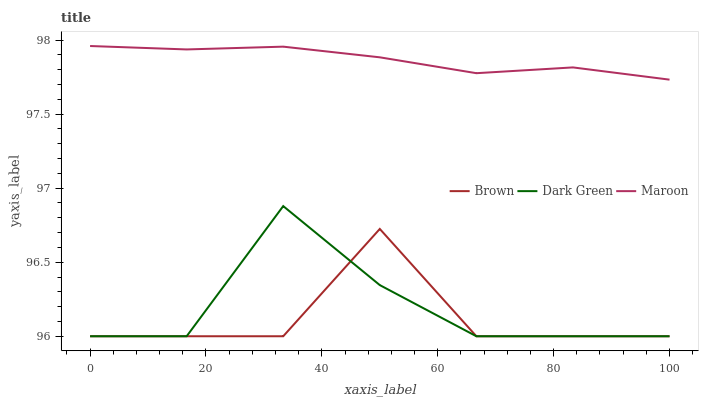Does Brown have the minimum area under the curve?
Answer yes or no. Yes. Does Maroon have the maximum area under the curve?
Answer yes or no. Yes. Does Dark Green have the minimum area under the curve?
Answer yes or no. No. Does Dark Green have the maximum area under the curve?
Answer yes or no. No. Is Maroon the smoothest?
Answer yes or no. Yes. Is Brown the roughest?
Answer yes or no. Yes. Is Dark Green the smoothest?
Answer yes or no. No. Is Dark Green the roughest?
Answer yes or no. No. Does Brown have the lowest value?
Answer yes or no. Yes. Does Maroon have the lowest value?
Answer yes or no. No. Does Maroon have the highest value?
Answer yes or no. Yes. Does Dark Green have the highest value?
Answer yes or no. No. Is Brown less than Maroon?
Answer yes or no. Yes. Is Maroon greater than Dark Green?
Answer yes or no. Yes. Does Dark Green intersect Brown?
Answer yes or no. Yes. Is Dark Green less than Brown?
Answer yes or no. No. Is Dark Green greater than Brown?
Answer yes or no. No. Does Brown intersect Maroon?
Answer yes or no. No. 